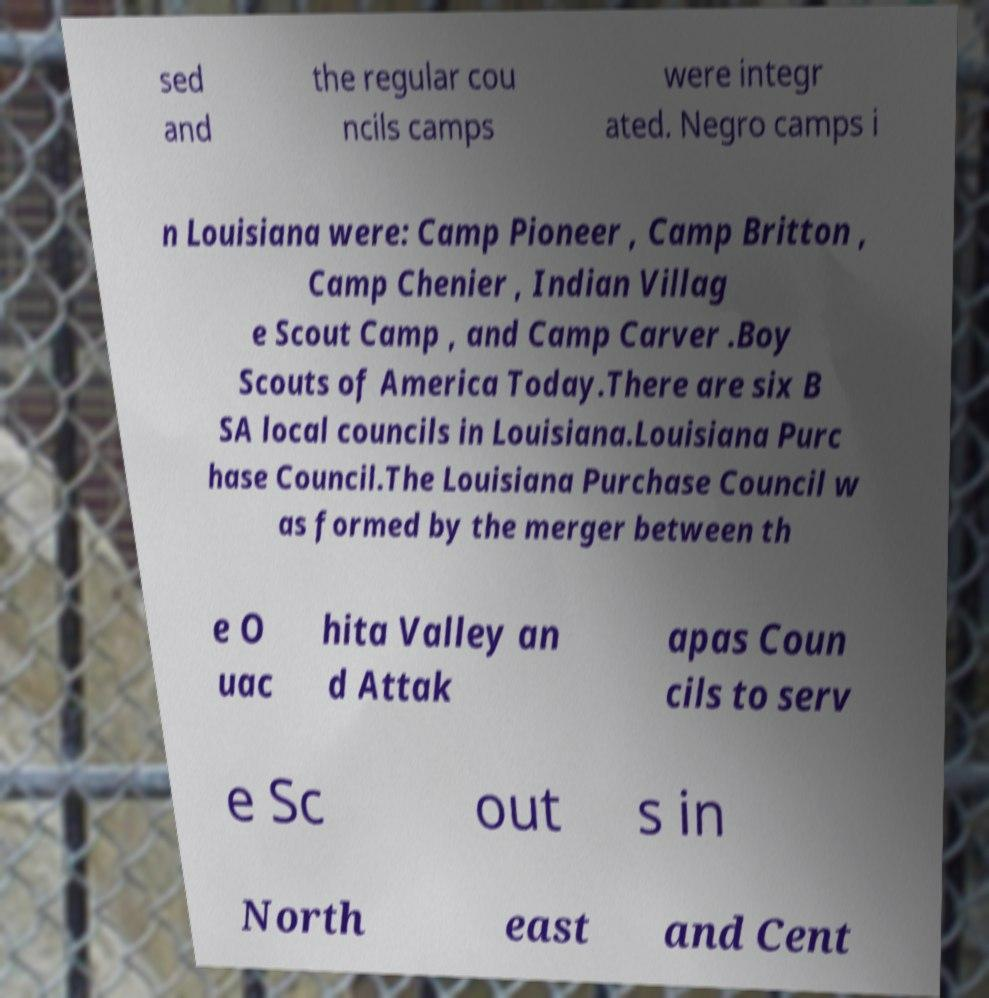Please read and relay the text visible in this image. What does it say? sed and the regular cou ncils camps were integr ated. Negro camps i n Louisiana were: Camp Pioneer , Camp Britton , Camp Chenier , Indian Villag e Scout Camp , and Camp Carver .Boy Scouts of America Today.There are six B SA local councils in Louisiana.Louisiana Purc hase Council.The Louisiana Purchase Council w as formed by the merger between th e O uac hita Valley an d Attak apas Coun cils to serv e Sc out s in North east and Cent 